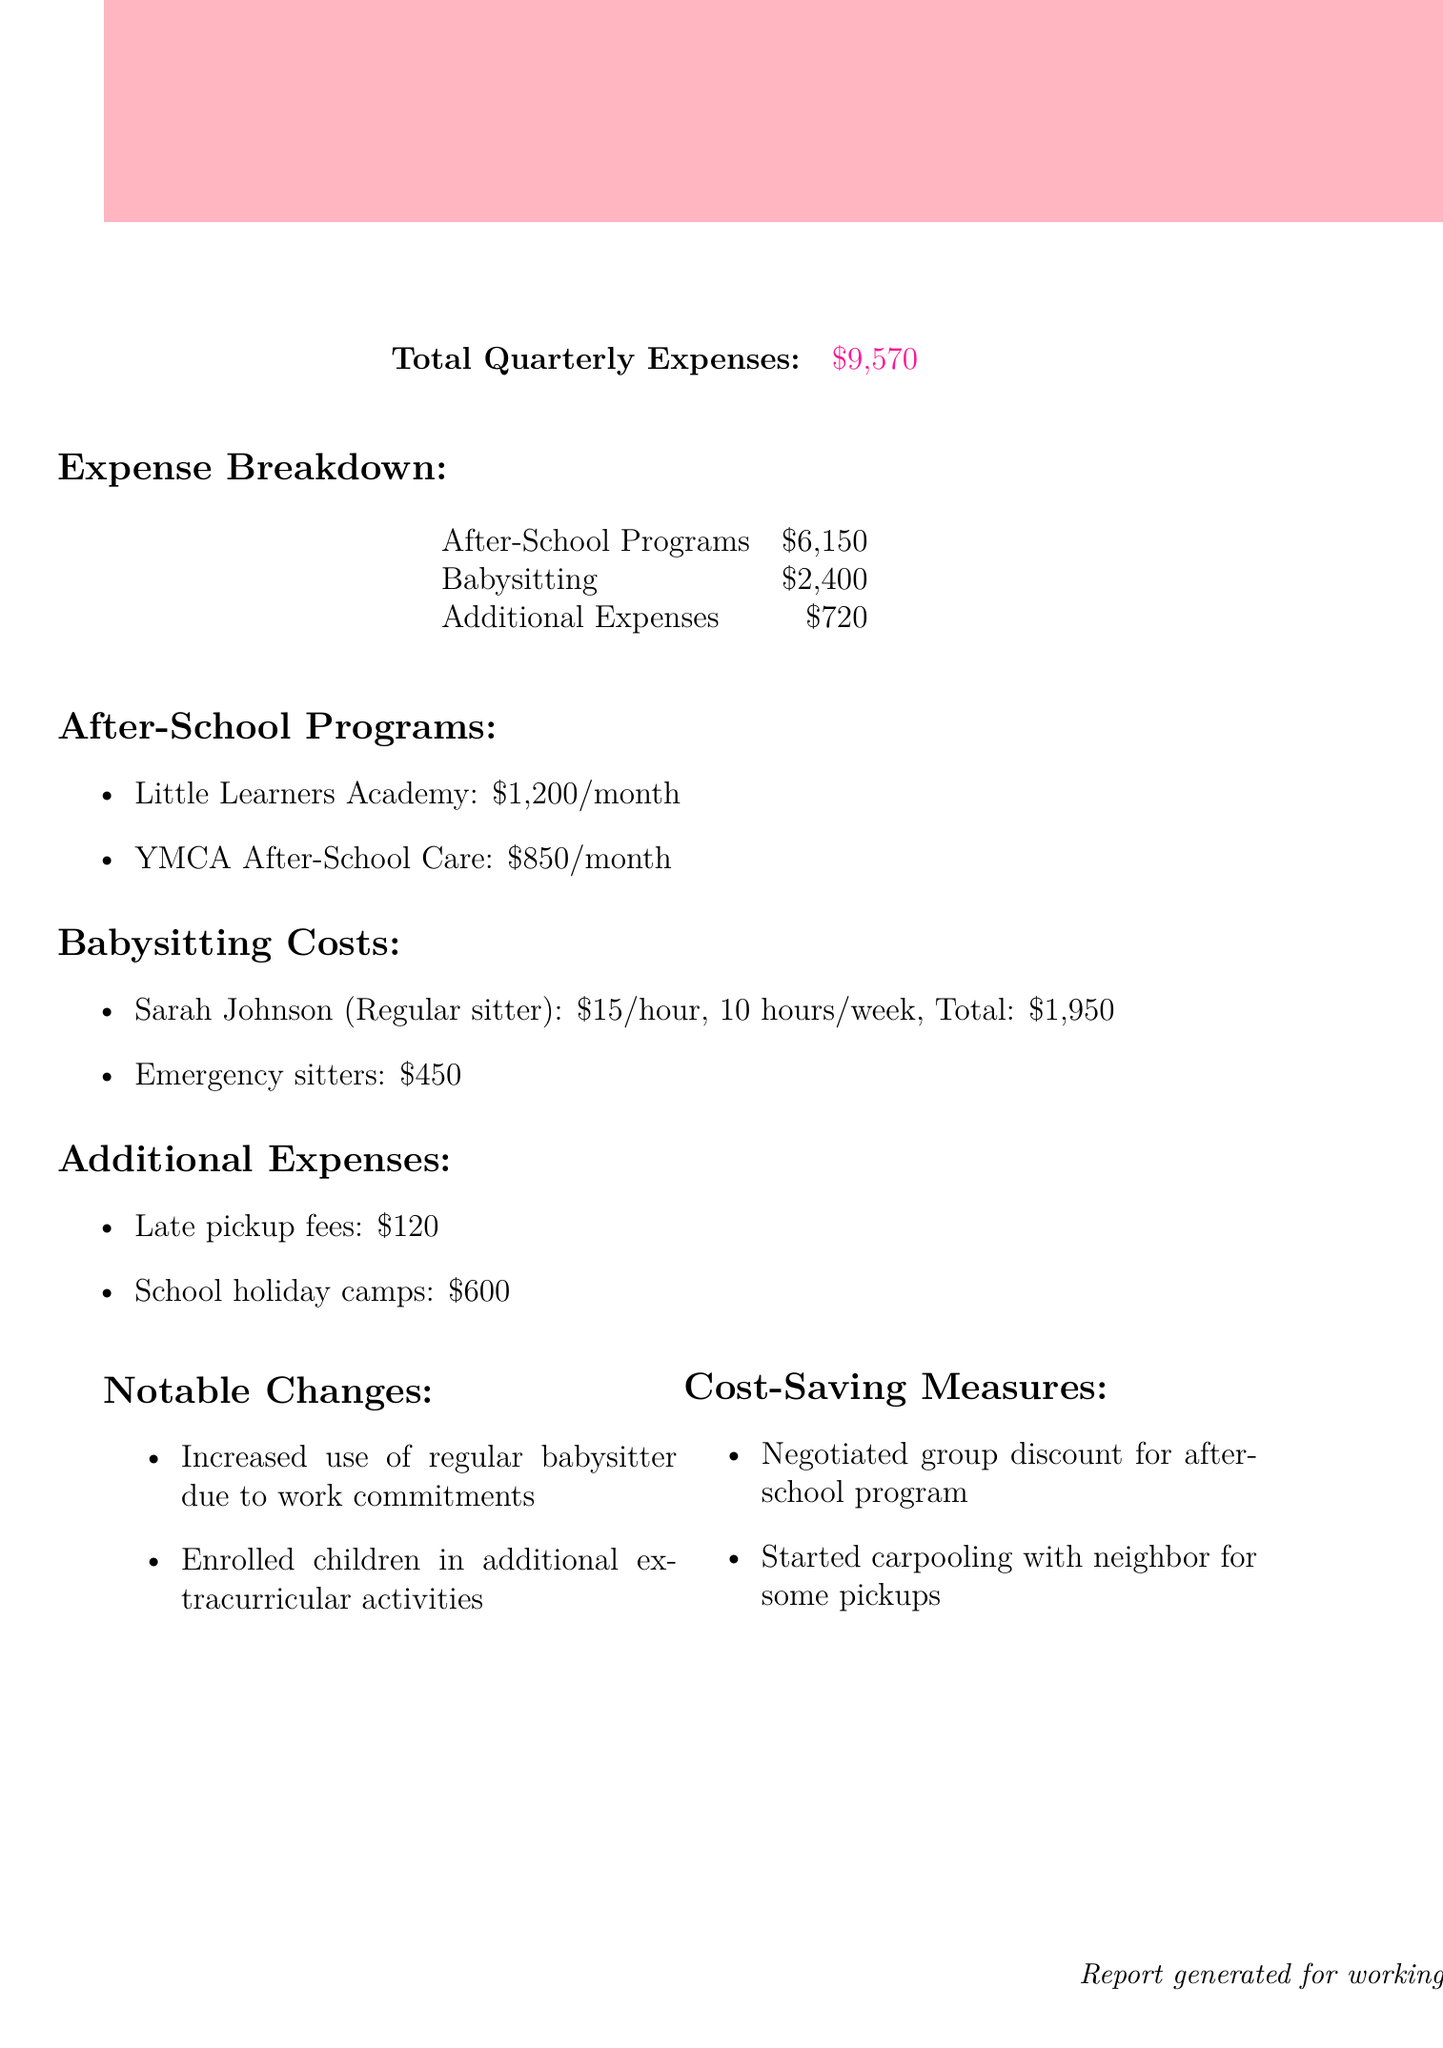What is the total quarterly expense? The total quarterly expense is listed in the document under total quarterly expenses.
Answer: $9,570 What is the cost of Little Learners Academy per month? The cost for Little Learners Academy is specified as a monthly cost in the after-school programs section.
Answer: $1,200 How much was spent on babysitting costs in total? The total babysitting costs are summed up in the expense breakdown section.
Answer: $2,400 What are late pickup fees? Late pickup fees are listed under additional expenses in the document, specifying the type of expense.
Answer: $120 What notable change occurred regarding babysitting? One of the notable changes mentioned in the document relates to the increased use of a regular babysitter.
Answer: Increased use of regular babysitter How much was spent on school holiday camps? The expense for school holiday camps can be found in the additional expenses section of the document.
Answer: $600 How frequently are payments made to YMCA After-School Care? The frequency of payments to YMCA After-School Care is indicated in the after-school programs section of the document.
Answer: Monthly What cost-saving measure was implemented? One of the cost-saving measures is mentioned under cost-saving measures, explaining the approach taken.
Answer: Negotiated group discount for after-school program How much was spent on additional expenses during the quarter? The total additional expenses figure can be found in the expense breakdown section.
Answer: $720 